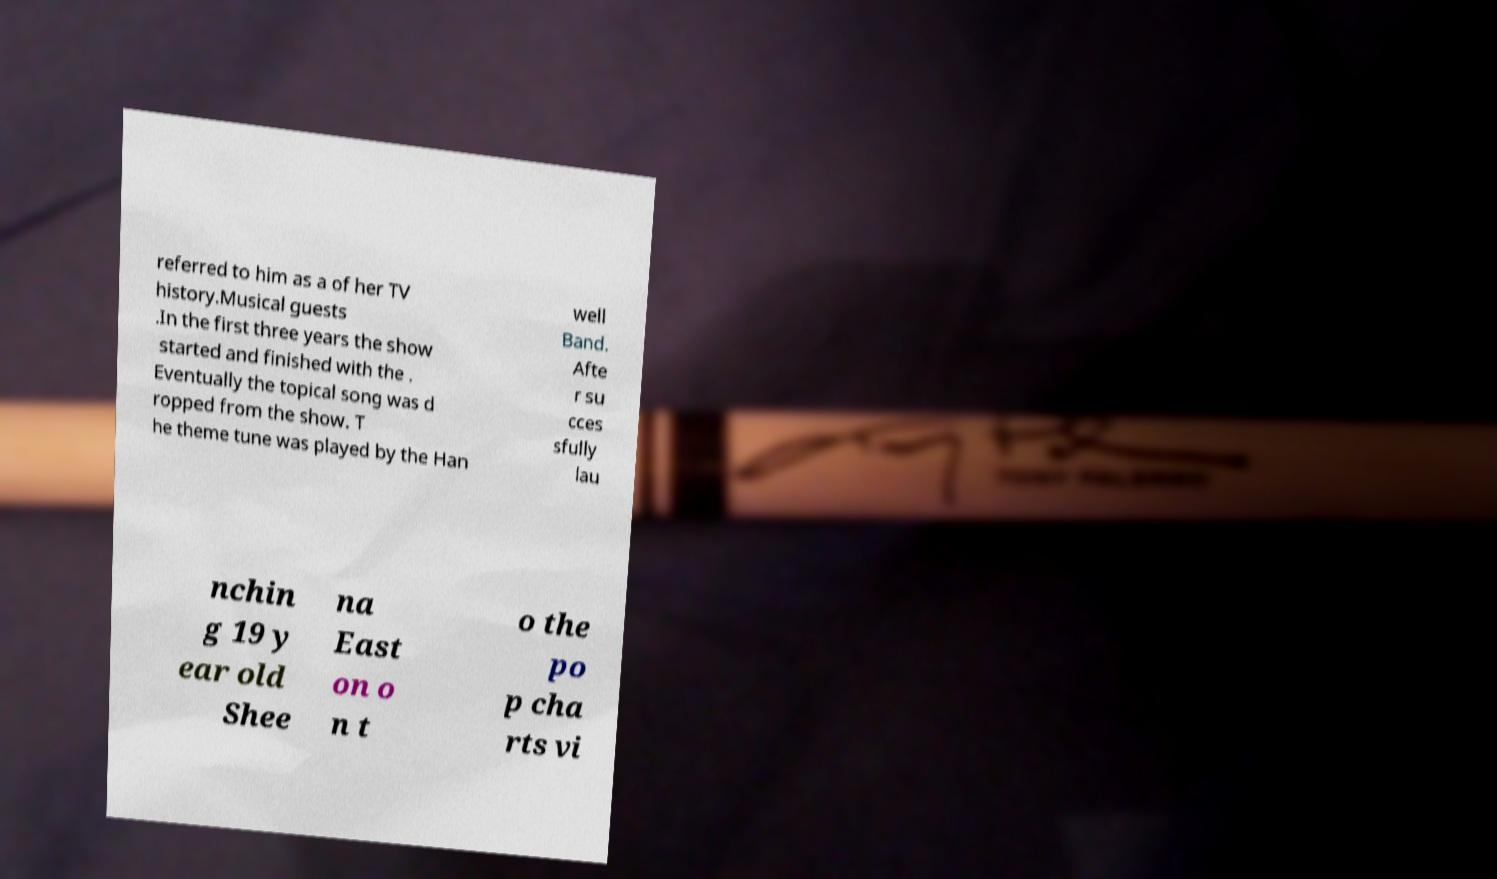Could you assist in decoding the text presented in this image and type it out clearly? referred to him as a of her TV history.Musical guests .In the first three years the show started and finished with the . Eventually the topical song was d ropped from the show. T he theme tune was played by the Han well Band. Afte r su cces sfully lau nchin g 19 y ear old Shee na East on o n t o the po p cha rts vi 